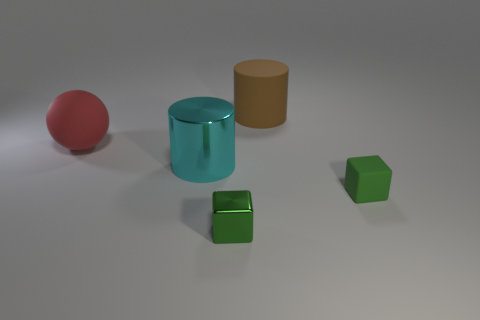Add 4 small metallic objects. How many objects exist? 9 Subtract all balls. How many objects are left? 4 Add 1 small green rubber things. How many small green rubber things exist? 2 Subtract 1 red spheres. How many objects are left? 4 Subtract all metal blocks. Subtract all blue metal spheres. How many objects are left? 4 Add 5 brown matte objects. How many brown matte objects are left? 6 